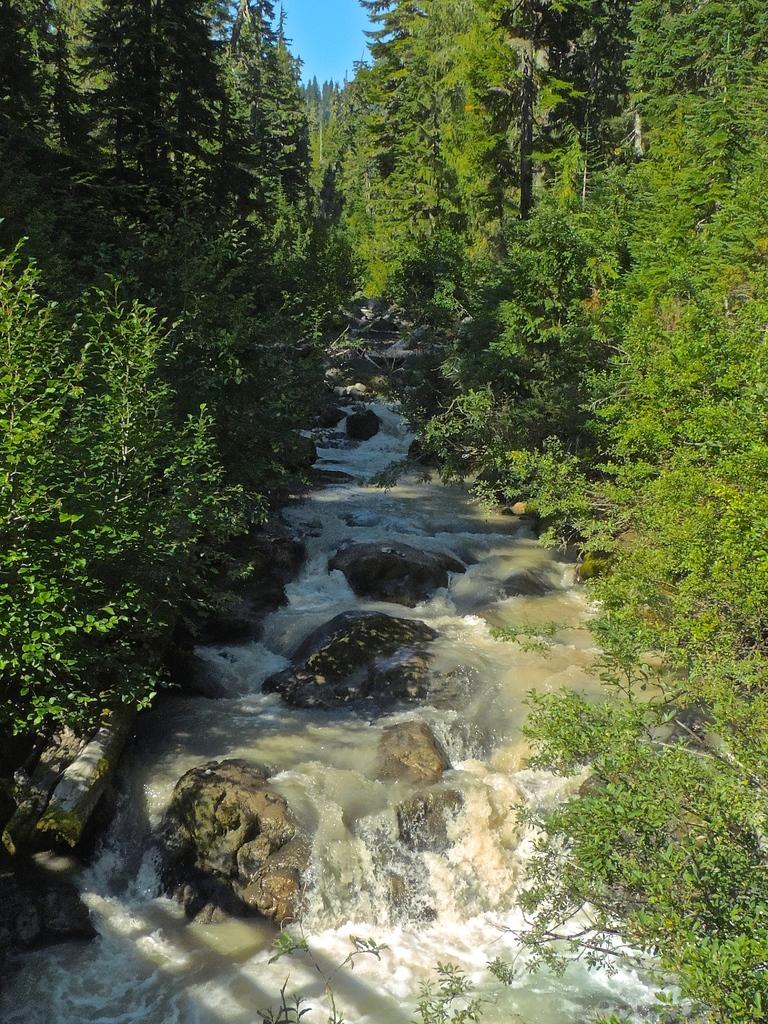What is present in the front of the image? There is water and stones in the front of the image. What can be seen in the background of the image? There are trees in the background of the image. How many times does the iron sneeze in the image? There is no iron present in the image, and therefore it cannot sneeze. 